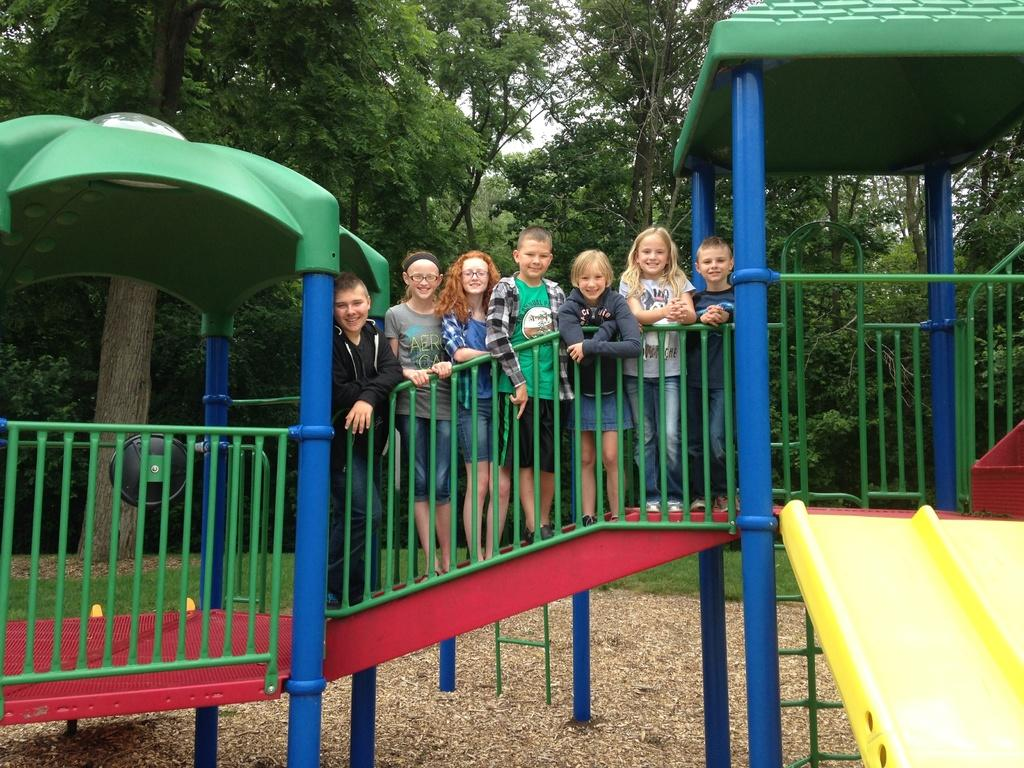What are the children doing in the image? The children are standing on the staircase. What can be seen at the top of the staircase? There are green color tents visible at the top. What type of natural elements are present in the image? Trees are visible in the image. What book is the child reading while standing on the staircase? There is no book visible in the image, and the children are not reading. 